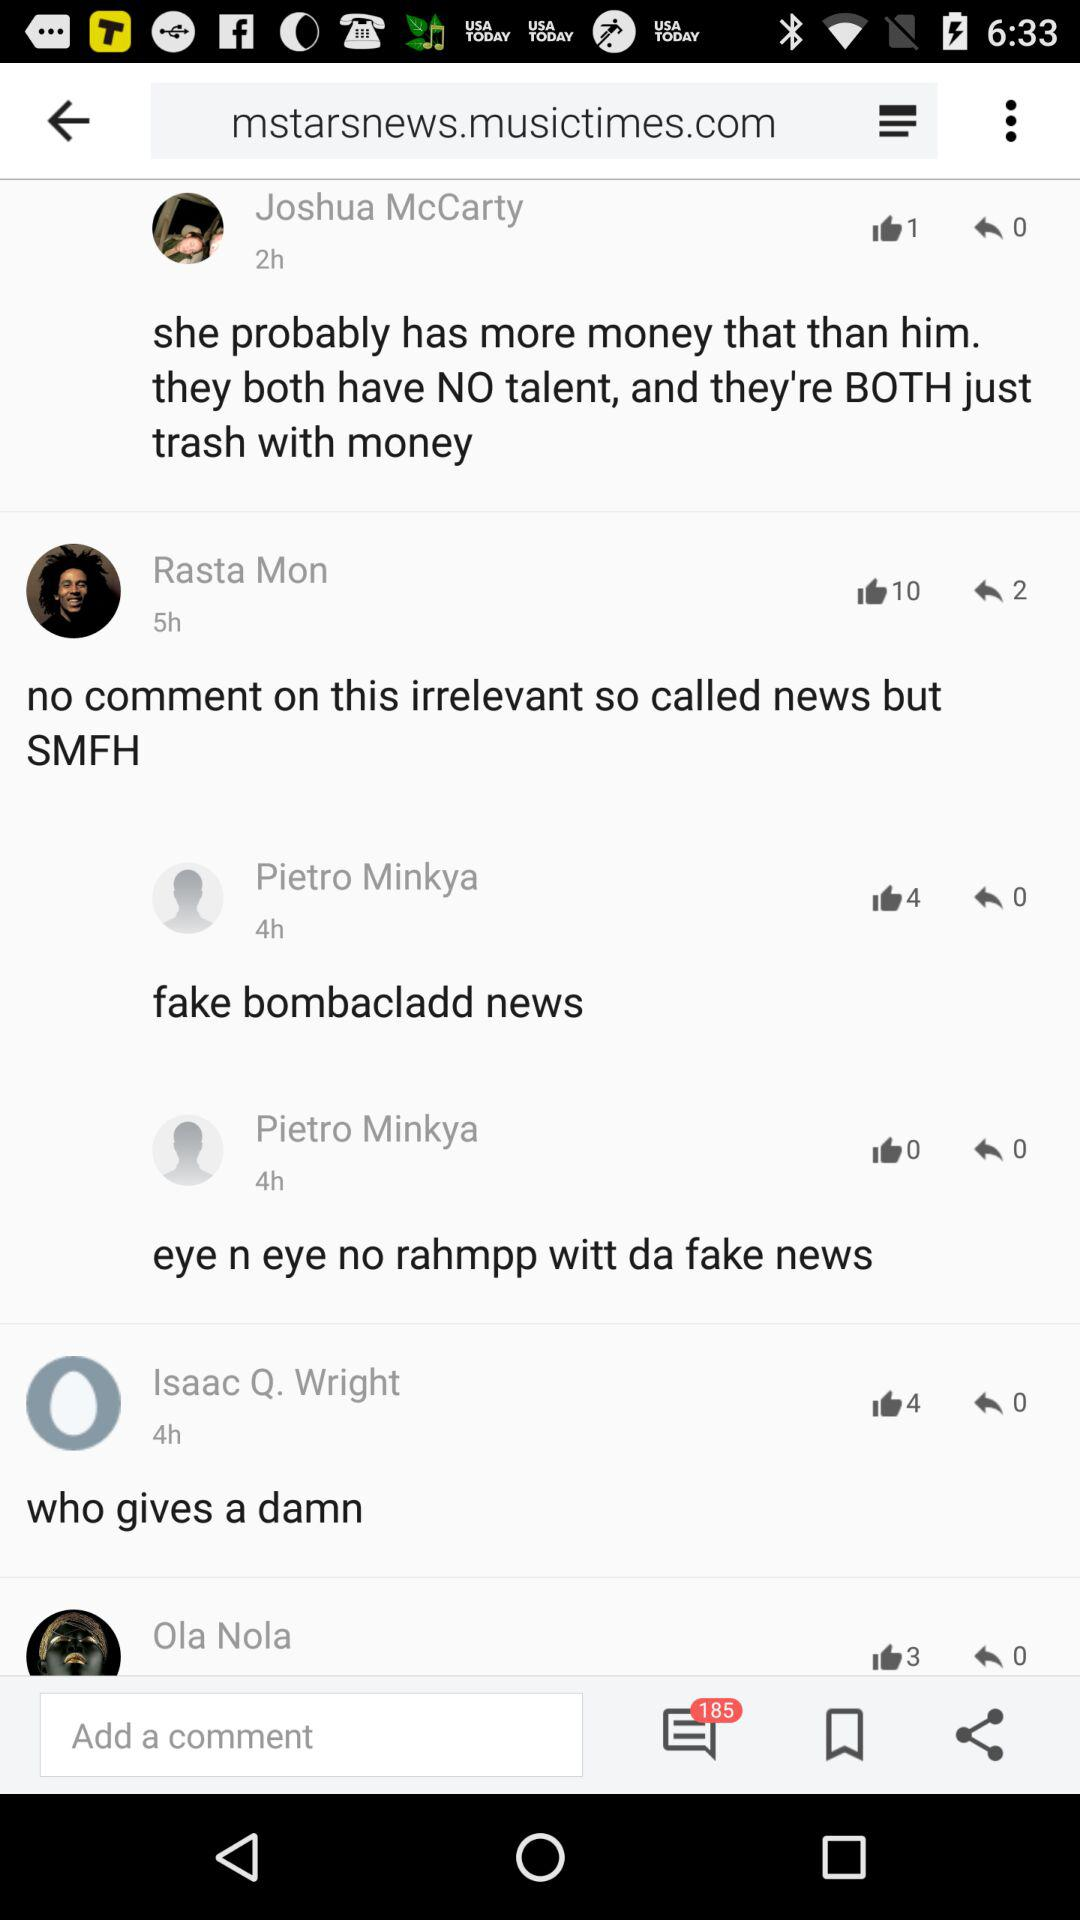How many comments are unread? There are 185 unread comments. 